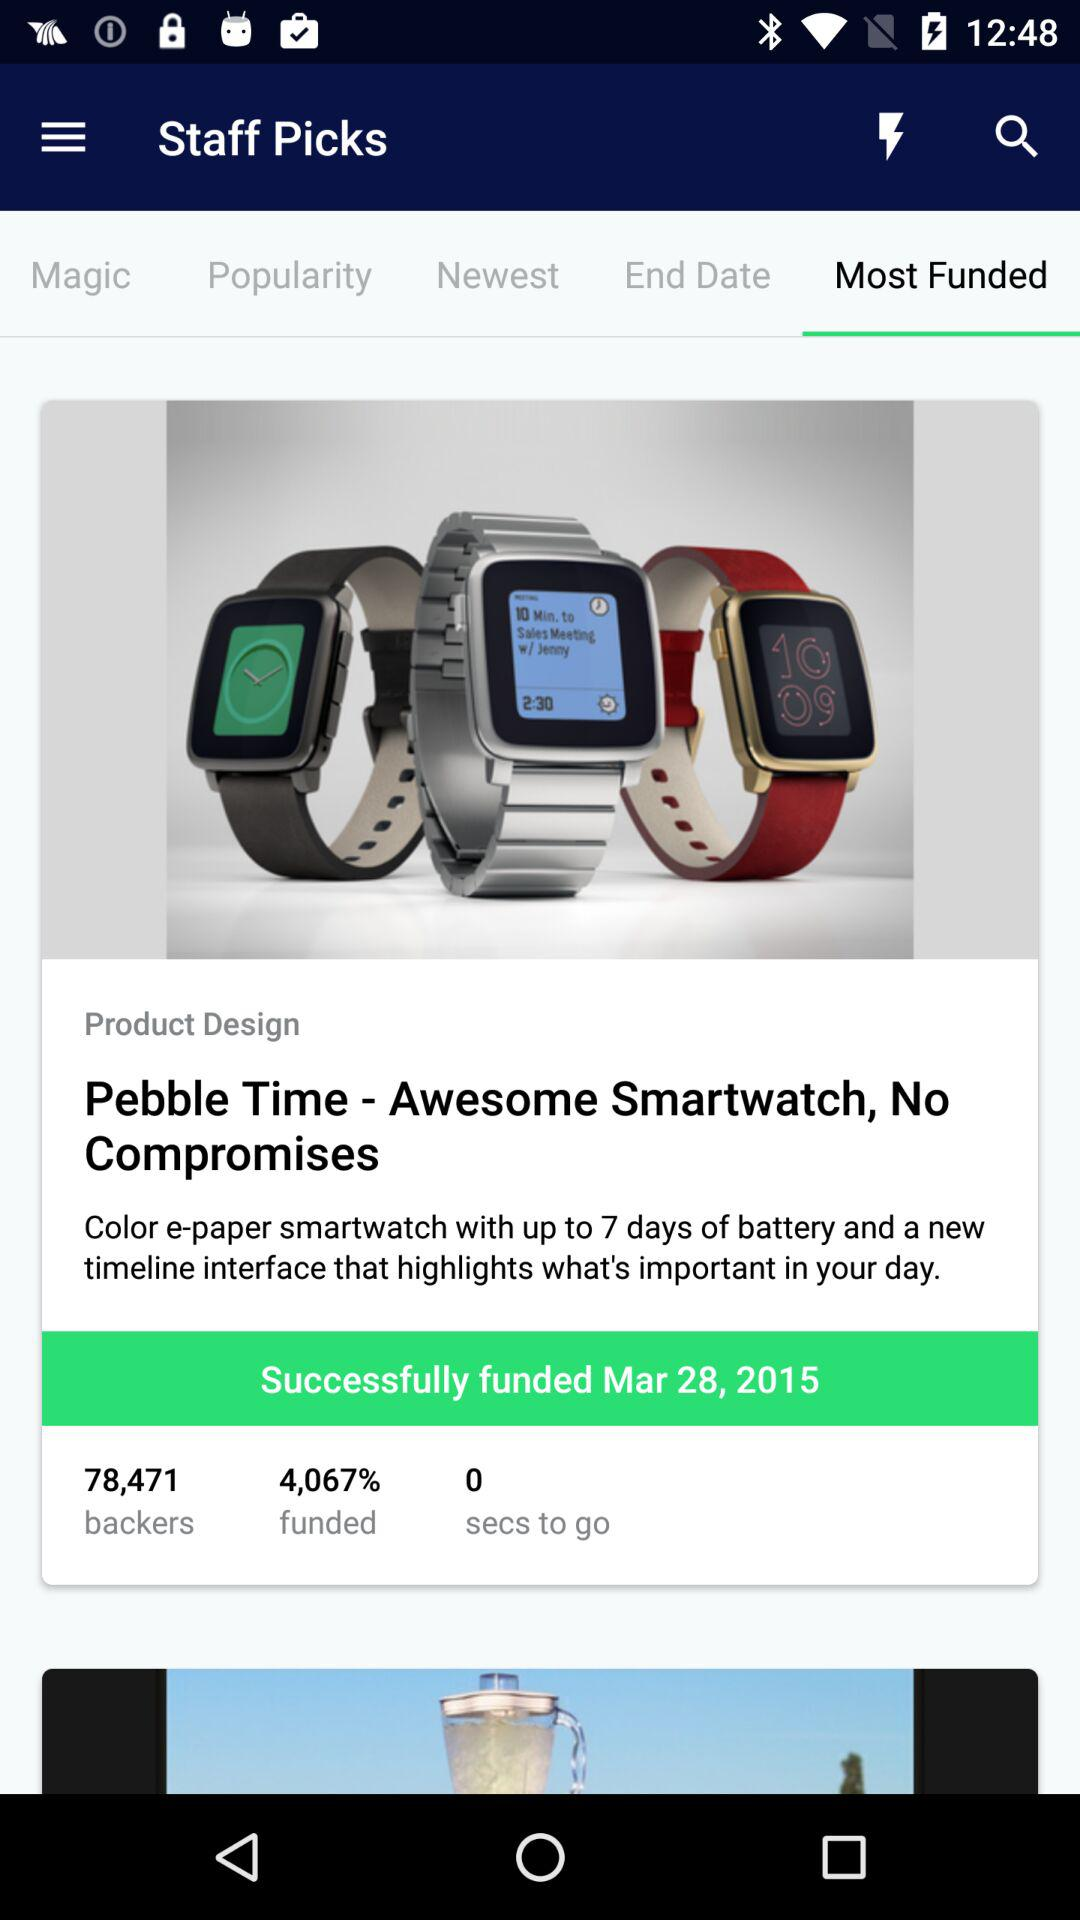What percentage of the Pebble Time's goal has been funded?
Answer the question using a single word or phrase. 4,067% 